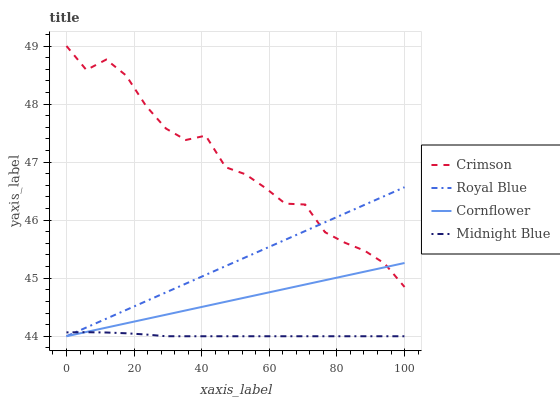Does Midnight Blue have the minimum area under the curve?
Answer yes or no. Yes. Does Crimson have the maximum area under the curve?
Answer yes or no. Yes. Does Royal Blue have the minimum area under the curve?
Answer yes or no. No. Does Royal Blue have the maximum area under the curve?
Answer yes or no. No. Is Cornflower the smoothest?
Answer yes or no. Yes. Is Crimson the roughest?
Answer yes or no. Yes. Is Royal Blue the smoothest?
Answer yes or no. No. Is Royal Blue the roughest?
Answer yes or no. No. Does Royal Blue have the lowest value?
Answer yes or no. Yes. Does Crimson have the highest value?
Answer yes or no. Yes. Does Royal Blue have the highest value?
Answer yes or no. No. Is Midnight Blue less than Crimson?
Answer yes or no. Yes. Is Crimson greater than Midnight Blue?
Answer yes or no. Yes. Does Midnight Blue intersect Cornflower?
Answer yes or no. Yes. Is Midnight Blue less than Cornflower?
Answer yes or no. No. Is Midnight Blue greater than Cornflower?
Answer yes or no. No. Does Midnight Blue intersect Crimson?
Answer yes or no. No. 